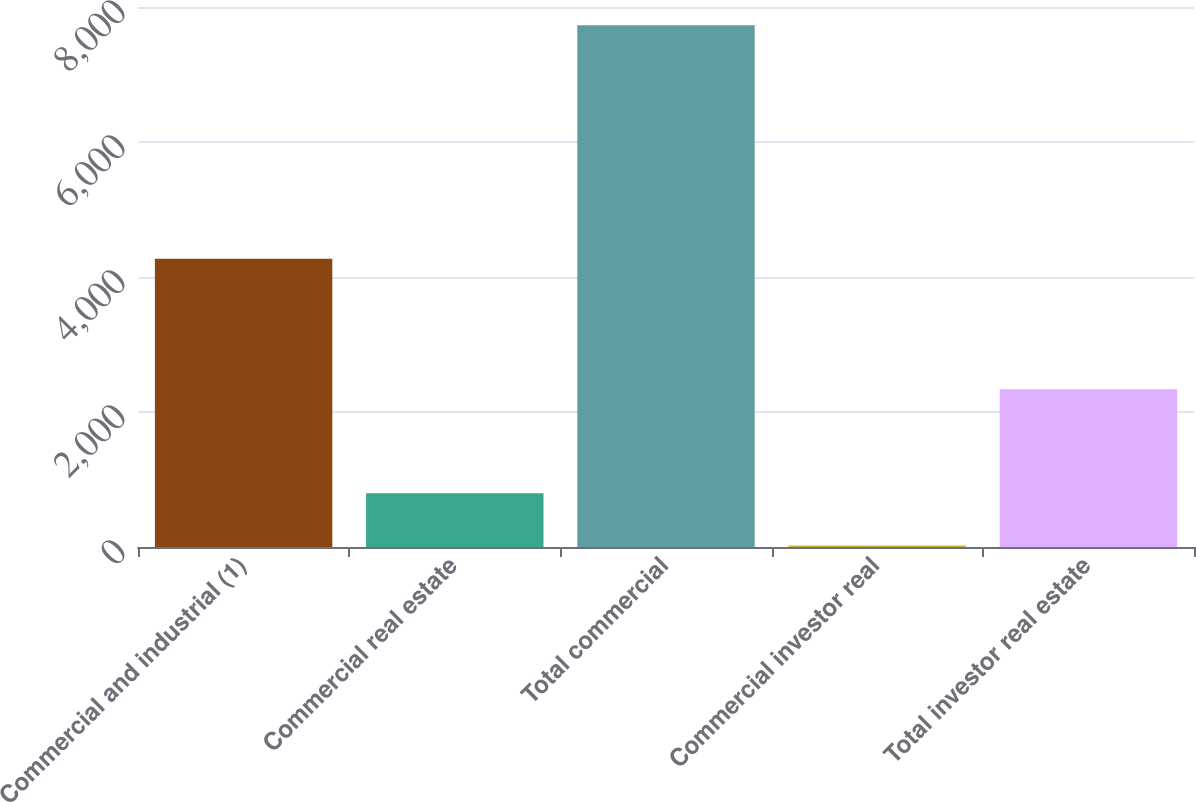Convert chart to OTSL. <chart><loc_0><loc_0><loc_500><loc_500><bar_chart><fcel>Commercial and industrial (1)<fcel>Commercial real estate<fcel>Total commercial<fcel>Commercial investor real<fcel>Total investor real estate<nl><fcel>4269<fcel>794.5<fcel>7729<fcel>24<fcel>2335.5<nl></chart> 